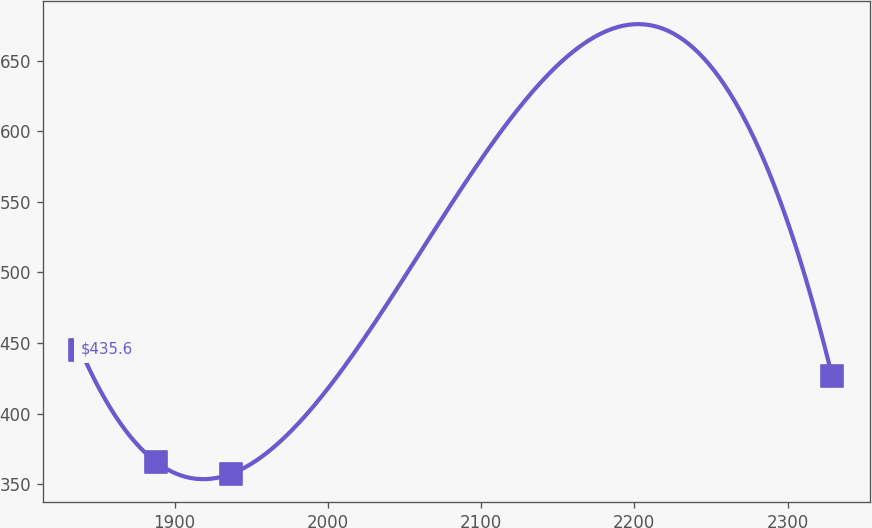Convert chart. <chart><loc_0><loc_0><loc_500><loc_500><line_chart><ecel><fcel>$435.6<nl><fcel>1838.46<fcel>445.29<nl><fcel>1887.53<fcel>365.99<nl><fcel>1936.6<fcel>357.18<nl><fcel>2329.17<fcel>426.25<nl></chart> 